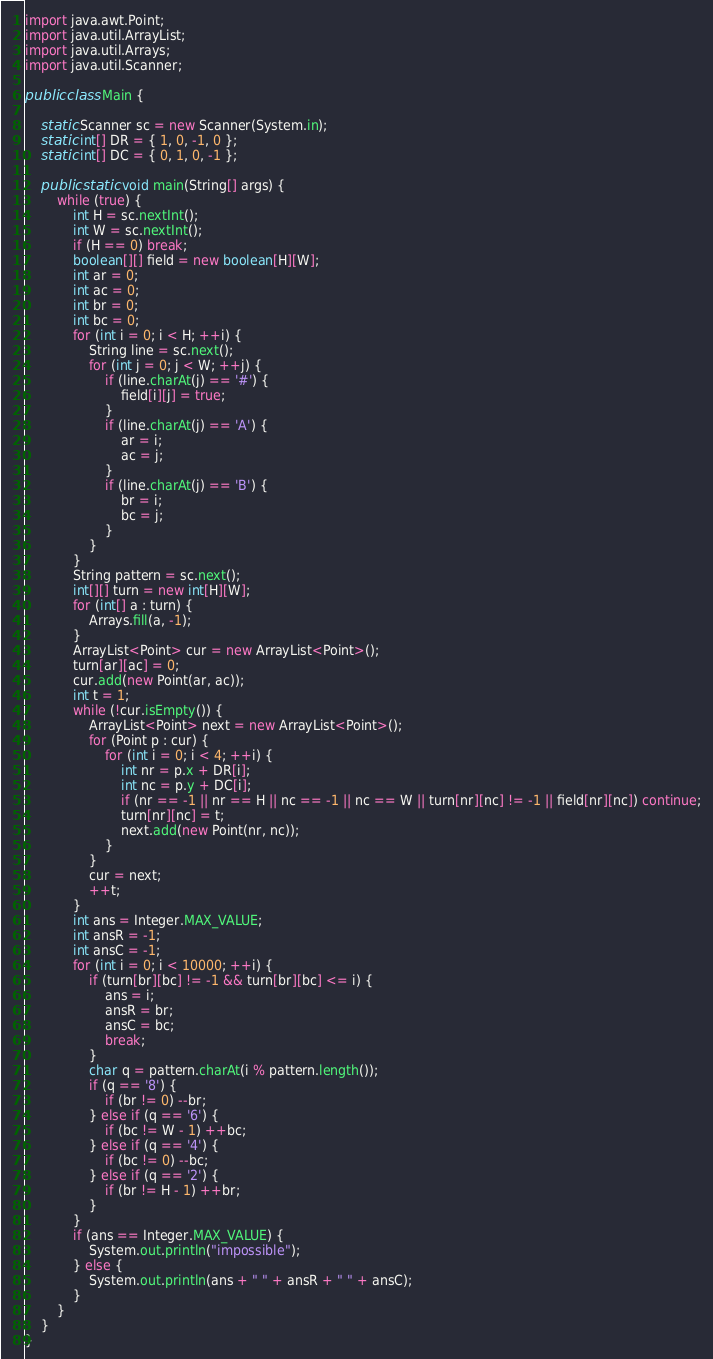Convert code to text. <code><loc_0><loc_0><loc_500><loc_500><_Java_>import java.awt.Point;
import java.util.ArrayList;
import java.util.Arrays;
import java.util.Scanner;

public class Main {

	static Scanner sc = new Scanner(System.in);
	static int[] DR = { 1, 0, -1, 0 };
	static int[] DC = { 0, 1, 0, -1 };

	public static void main(String[] args) {
		while (true) {
			int H = sc.nextInt();
			int W = sc.nextInt();
			if (H == 0) break;
			boolean[][] field = new boolean[H][W];
			int ar = 0;
			int ac = 0;
			int br = 0;
			int bc = 0;
			for (int i = 0; i < H; ++i) {
				String line = sc.next();
				for (int j = 0; j < W; ++j) {
					if (line.charAt(j) == '#') {
						field[i][j] = true;
					}
					if (line.charAt(j) == 'A') {
						ar = i;
						ac = j;
					}
					if (line.charAt(j) == 'B') {
						br = i;
						bc = j;
					}
				}
			}
			String pattern = sc.next();
			int[][] turn = new int[H][W];
			for (int[] a : turn) {
				Arrays.fill(a, -1);
			}
			ArrayList<Point> cur = new ArrayList<Point>();
			turn[ar][ac] = 0;
			cur.add(new Point(ar, ac));
			int t = 1;
			while (!cur.isEmpty()) {
				ArrayList<Point> next = new ArrayList<Point>();
				for (Point p : cur) {
					for (int i = 0; i < 4; ++i) {
						int nr = p.x + DR[i];
						int nc = p.y + DC[i];
						if (nr == -1 || nr == H || nc == -1 || nc == W || turn[nr][nc] != -1 || field[nr][nc]) continue;
						turn[nr][nc] = t;
						next.add(new Point(nr, nc));
					}
				}
				cur = next;
				++t;
			}
			int ans = Integer.MAX_VALUE;
			int ansR = -1;
			int ansC = -1;
			for (int i = 0; i < 10000; ++i) {
				if (turn[br][bc] != -1 && turn[br][bc] <= i) {
					ans = i;
					ansR = br;
					ansC = bc;
					break;
				}
				char q = pattern.charAt(i % pattern.length());
				if (q == '8') {
					if (br != 0) --br;
				} else if (q == '6') {
					if (bc != W - 1) ++bc;
				} else if (q == '4') {
					if (bc != 0) --bc;
				} else if (q == '2') {
					if (br != H - 1) ++br;
				}
			}
			if (ans == Integer.MAX_VALUE) {
				System.out.println("impossible");
			} else {
				System.out.println(ans + " " + ansR + " " + ansC);
			}
		}
	}
}</code> 